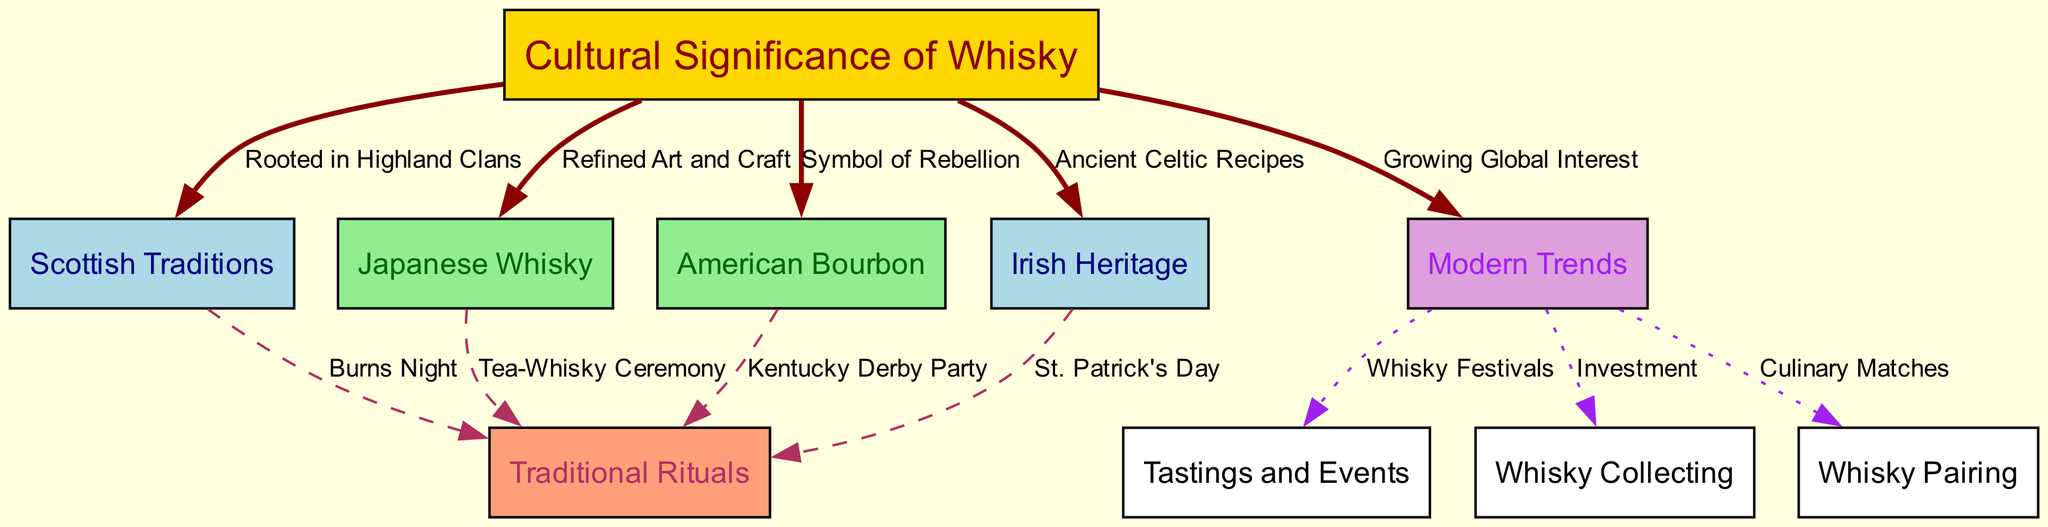What is the central theme of the diagram? The central theme, represented by the main node, is the "Cultural Significance of Whisky." This node is the starting point from which all other themes branch out.
Answer: Cultural Significance of Whisky How many traditional rituals are listed? The edges stemming from "traditional_rituals" indicate four traditional rituals present in the diagram: Burns Night, Tea-Whisky Ceremony, Kentucky Derby Party, and St. Patrick's Day. Counting these, we arrive at the total number.
Answer: 4 Which whisky tradition is known for its "Refined Art and Craft"? The edge connecting "Cultural Significance of Whisky" to "Japanese Whisky" specifies that Japanese whisky is recognized for its refined art and craft, denoting cultural importance in its production methods.
Answer: Japanese Whisky What is one modern trend associated with whisky? The edge linking "Modern Trends" to "Tastings and Events" indicates whisky festivals as a growing modern trend, showcasing how whisky culture has evolved and integrated into contemporary experiences.
Answer: Tastings and Events Which type of whisky is described as a "Symbol of Rebellion"? The edge from "Cultural Significance of Whisky" to "American Bourbon" explicitly states that American bourbon is regarded as a symbol of rebellion, highlighting its cultural narrative in history.
Answer: American Bourbon What connects Scottish traditions to its traditional rituals? The arrow labeled "Burns Night" connects "Scottish Traditions" to "Traditional Rituals," indicating a specific event that embodies cultural and social practices associated with Scotch whisky.
Answer: Burns Night What emerging trend relates to whisky collecting? The association between "Modern Trends" and "Whisky Collecting," highlighted by an edge labeled "Investment," shows that whisky collecting is increasingly viewed as a viable investment opportunity.
Answer: Investment What cultural significance is associated with Irish Heritage? The edge connecting "Cultural Significance of Whisky" to "Irish Heritage" states "Ancient Celtic Recipes," revealing the deep historical and cultural roots that Irish heritage brings to whisky production.
Answer: Ancient Celtic Recipes What is the relationship between "Japanese Whisky" and traditional rituals? The connection is established by the edge labeled "Tea-Whisky Ceremony," demonstrating the specific traditional ritual tied to Japanese whisky and showcasing its cultural significance.
Answer: Tea-Whisky Ceremony 